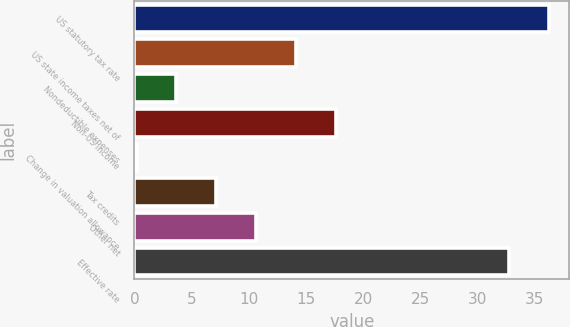<chart> <loc_0><loc_0><loc_500><loc_500><bar_chart><fcel>US statutory tax rate<fcel>US state income taxes net of<fcel>Nondeductible expenses<fcel>Non-US income<fcel>Change in valuation allowance<fcel>Tax credits<fcel>Other net<fcel>Effective rate<nl><fcel>36.18<fcel>14.12<fcel>3.68<fcel>17.6<fcel>0.2<fcel>7.16<fcel>10.64<fcel>32.7<nl></chart> 